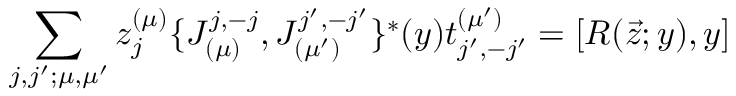Convert formula to latex. <formula><loc_0><loc_0><loc_500><loc_500>\sum _ { j , j ^ { \prime } ; \mu , \mu ^ { \prime } } z _ { j } ^ { ( \mu ) } \{ J _ { ( \mu ) } ^ { j , - j } , J _ { ( \mu ^ { \prime } ) } ^ { j ^ { \prime } , - j ^ { \prime } } \} ^ { * } ( y ) t _ { j ^ { \prime } , - j ^ { \prime } } ^ { ( \mu ^ { \prime } ) } = [ R ( \vec { z } ; y ) , y ]</formula> 